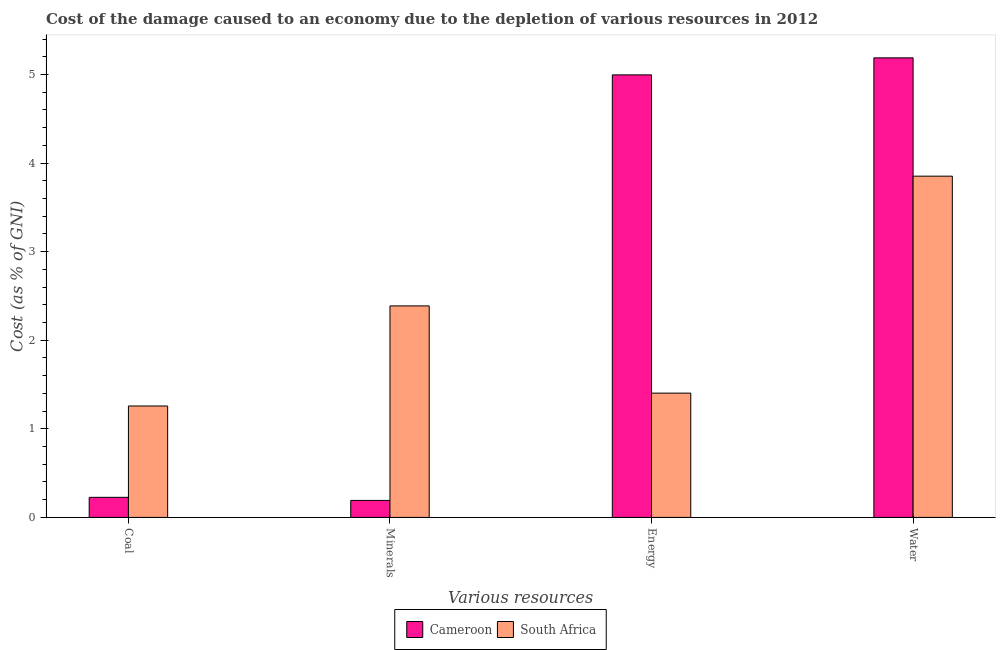How many different coloured bars are there?
Ensure brevity in your answer.  2. How many groups of bars are there?
Ensure brevity in your answer.  4. Are the number of bars per tick equal to the number of legend labels?
Give a very brief answer. Yes. How many bars are there on the 3rd tick from the left?
Offer a very short reply. 2. What is the label of the 3rd group of bars from the left?
Provide a succinct answer. Energy. What is the cost of damage due to depletion of coal in South Africa?
Offer a terse response. 1.26. Across all countries, what is the maximum cost of damage due to depletion of energy?
Offer a very short reply. 5. Across all countries, what is the minimum cost of damage due to depletion of coal?
Offer a terse response. 0.23. In which country was the cost of damage due to depletion of minerals maximum?
Offer a very short reply. South Africa. In which country was the cost of damage due to depletion of coal minimum?
Make the answer very short. Cameroon. What is the total cost of damage due to depletion of energy in the graph?
Provide a short and direct response. 6.4. What is the difference between the cost of damage due to depletion of energy in Cameroon and that in South Africa?
Ensure brevity in your answer.  3.59. What is the difference between the cost of damage due to depletion of water in South Africa and the cost of damage due to depletion of energy in Cameroon?
Offer a very short reply. -1.14. What is the average cost of damage due to depletion of coal per country?
Give a very brief answer. 0.74. What is the difference between the cost of damage due to depletion of energy and cost of damage due to depletion of minerals in Cameroon?
Provide a short and direct response. 4.8. What is the ratio of the cost of damage due to depletion of minerals in Cameroon to that in South Africa?
Offer a very short reply. 0.08. Is the cost of damage due to depletion of energy in Cameroon less than that in South Africa?
Give a very brief answer. No. Is the difference between the cost of damage due to depletion of coal in Cameroon and South Africa greater than the difference between the cost of damage due to depletion of energy in Cameroon and South Africa?
Your answer should be compact. No. What is the difference between the highest and the second highest cost of damage due to depletion of energy?
Offer a terse response. 3.59. What is the difference between the highest and the lowest cost of damage due to depletion of energy?
Give a very brief answer. 3.59. Is it the case that in every country, the sum of the cost of damage due to depletion of minerals and cost of damage due to depletion of coal is greater than the sum of cost of damage due to depletion of water and cost of damage due to depletion of energy?
Your answer should be compact. No. What does the 1st bar from the left in Energy represents?
Your response must be concise. Cameroon. What does the 2nd bar from the right in Minerals represents?
Give a very brief answer. Cameroon. Is it the case that in every country, the sum of the cost of damage due to depletion of coal and cost of damage due to depletion of minerals is greater than the cost of damage due to depletion of energy?
Offer a very short reply. No. Are the values on the major ticks of Y-axis written in scientific E-notation?
Make the answer very short. No. Does the graph contain grids?
Your answer should be very brief. No. Where does the legend appear in the graph?
Make the answer very short. Bottom center. What is the title of the graph?
Ensure brevity in your answer.  Cost of the damage caused to an economy due to the depletion of various resources in 2012 . Does "Iceland" appear as one of the legend labels in the graph?
Make the answer very short. No. What is the label or title of the X-axis?
Offer a terse response. Various resources. What is the label or title of the Y-axis?
Your answer should be very brief. Cost (as % of GNI). What is the Cost (as % of GNI) in Cameroon in Coal?
Give a very brief answer. 0.23. What is the Cost (as % of GNI) in South Africa in Coal?
Make the answer very short. 1.26. What is the Cost (as % of GNI) of Cameroon in Minerals?
Give a very brief answer. 0.19. What is the Cost (as % of GNI) in South Africa in Minerals?
Offer a very short reply. 2.39. What is the Cost (as % of GNI) of Cameroon in Energy?
Offer a terse response. 5. What is the Cost (as % of GNI) of South Africa in Energy?
Provide a succinct answer. 1.4. What is the Cost (as % of GNI) of Cameroon in Water?
Give a very brief answer. 5.19. What is the Cost (as % of GNI) in South Africa in Water?
Ensure brevity in your answer.  3.85. Across all Various resources, what is the maximum Cost (as % of GNI) in Cameroon?
Give a very brief answer. 5.19. Across all Various resources, what is the maximum Cost (as % of GNI) of South Africa?
Ensure brevity in your answer.  3.85. Across all Various resources, what is the minimum Cost (as % of GNI) in Cameroon?
Your response must be concise. 0.19. Across all Various resources, what is the minimum Cost (as % of GNI) of South Africa?
Your response must be concise. 1.26. What is the total Cost (as % of GNI) in Cameroon in the graph?
Make the answer very short. 10.6. What is the total Cost (as % of GNI) of South Africa in the graph?
Your response must be concise. 8.9. What is the difference between the Cost (as % of GNI) of Cameroon in Coal and that in Minerals?
Provide a succinct answer. 0.03. What is the difference between the Cost (as % of GNI) of South Africa in Coal and that in Minerals?
Make the answer very short. -1.13. What is the difference between the Cost (as % of GNI) in Cameroon in Coal and that in Energy?
Ensure brevity in your answer.  -4.77. What is the difference between the Cost (as % of GNI) of South Africa in Coal and that in Energy?
Offer a terse response. -0.15. What is the difference between the Cost (as % of GNI) in Cameroon in Coal and that in Water?
Keep it short and to the point. -4.96. What is the difference between the Cost (as % of GNI) in South Africa in Coal and that in Water?
Your response must be concise. -2.59. What is the difference between the Cost (as % of GNI) in Cameroon in Minerals and that in Energy?
Your answer should be very brief. -4.8. What is the difference between the Cost (as % of GNI) in Cameroon in Minerals and that in Water?
Your response must be concise. -5. What is the difference between the Cost (as % of GNI) of South Africa in Minerals and that in Water?
Keep it short and to the point. -1.46. What is the difference between the Cost (as % of GNI) in Cameroon in Energy and that in Water?
Make the answer very short. -0.19. What is the difference between the Cost (as % of GNI) in South Africa in Energy and that in Water?
Your answer should be very brief. -2.45. What is the difference between the Cost (as % of GNI) of Cameroon in Coal and the Cost (as % of GNI) of South Africa in Minerals?
Make the answer very short. -2.16. What is the difference between the Cost (as % of GNI) in Cameroon in Coal and the Cost (as % of GNI) in South Africa in Energy?
Your answer should be compact. -1.18. What is the difference between the Cost (as % of GNI) in Cameroon in Coal and the Cost (as % of GNI) in South Africa in Water?
Your answer should be very brief. -3.63. What is the difference between the Cost (as % of GNI) of Cameroon in Minerals and the Cost (as % of GNI) of South Africa in Energy?
Give a very brief answer. -1.21. What is the difference between the Cost (as % of GNI) in Cameroon in Minerals and the Cost (as % of GNI) in South Africa in Water?
Your answer should be very brief. -3.66. What is the difference between the Cost (as % of GNI) of Cameroon in Energy and the Cost (as % of GNI) of South Africa in Water?
Provide a succinct answer. 1.14. What is the average Cost (as % of GNI) of Cameroon per Various resources?
Your answer should be very brief. 2.65. What is the average Cost (as % of GNI) in South Africa per Various resources?
Your answer should be compact. 2.23. What is the difference between the Cost (as % of GNI) of Cameroon and Cost (as % of GNI) of South Africa in Coal?
Ensure brevity in your answer.  -1.03. What is the difference between the Cost (as % of GNI) in Cameroon and Cost (as % of GNI) in South Africa in Minerals?
Provide a short and direct response. -2.2. What is the difference between the Cost (as % of GNI) of Cameroon and Cost (as % of GNI) of South Africa in Energy?
Offer a terse response. 3.59. What is the difference between the Cost (as % of GNI) in Cameroon and Cost (as % of GNI) in South Africa in Water?
Your response must be concise. 1.34. What is the ratio of the Cost (as % of GNI) of Cameroon in Coal to that in Minerals?
Your answer should be compact. 1.18. What is the ratio of the Cost (as % of GNI) in South Africa in Coal to that in Minerals?
Your response must be concise. 0.53. What is the ratio of the Cost (as % of GNI) in Cameroon in Coal to that in Energy?
Make the answer very short. 0.05. What is the ratio of the Cost (as % of GNI) of South Africa in Coal to that in Energy?
Provide a succinct answer. 0.9. What is the ratio of the Cost (as % of GNI) in Cameroon in Coal to that in Water?
Provide a short and direct response. 0.04. What is the ratio of the Cost (as % of GNI) of South Africa in Coal to that in Water?
Give a very brief answer. 0.33. What is the ratio of the Cost (as % of GNI) of Cameroon in Minerals to that in Energy?
Offer a terse response. 0.04. What is the ratio of the Cost (as % of GNI) in South Africa in Minerals to that in Energy?
Provide a succinct answer. 1.7. What is the ratio of the Cost (as % of GNI) in Cameroon in Minerals to that in Water?
Ensure brevity in your answer.  0.04. What is the ratio of the Cost (as % of GNI) in South Africa in Minerals to that in Water?
Ensure brevity in your answer.  0.62. What is the ratio of the Cost (as % of GNI) in South Africa in Energy to that in Water?
Your answer should be very brief. 0.36. What is the difference between the highest and the second highest Cost (as % of GNI) of Cameroon?
Your response must be concise. 0.19. What is the difference between the highest and the second highest Cost (as % of GNI) of South Africa?
Keep it short and to the point. 1.46. What is the difference between the highest and the lowest Cost (as % of GNI) in Cameroon?
Ensure brevity in your answer.  5. What is the difference between the highest and the lowest Cost (as % of GNI) of South Africa?
Offer a very short reply. 2.59. 